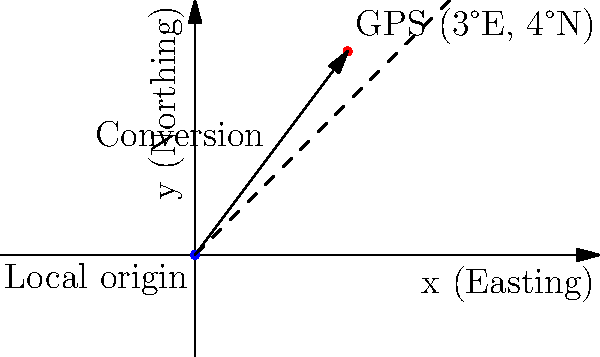In a coastal erosion property dispute case, you need to convert GPS coordinates to a local coordinate system. Given a GPS coordinate of 3°E longitude and 4°N latitude, and knowing that the local coordinate system's origin is at (0,0) in the GPS system, what would be the coordinates of the point in the local system, assuming 1 degree equals 100 km and the local system uses meters? To convert the GPS coordinates to the local coordinate system, we need to follow these steps:

1. Understand the given information:
   - GPS coordinate: (3°E, 4°N)
   - Local system origin: (0°E, 0°N) in GPS
   - 1 degree = 100 km = 100,000 m

2. Calculate the difference between the GPS point and the local origin:
   - Easting: 3° - 0° = 3°
   - Northing: 4° - 0° = 4°

3. Convert the differences from degrees to meters:
   - Easting: 3° × 100,000 m/° = 300,000 m
   - Northing: 4° × 100,000 m/° = 400,000 m

4. The resulting coordinates in the local system are:
   - x (Easting) = 300,000 m
   - y (Northing) = 400,000 m

Therefore, the point (3°E, 4°N) in the GPS system corresponds to (300,000 m, 400,000 m) in the local coordinate system.
Answer: (300,000 m, 400,000 m) 